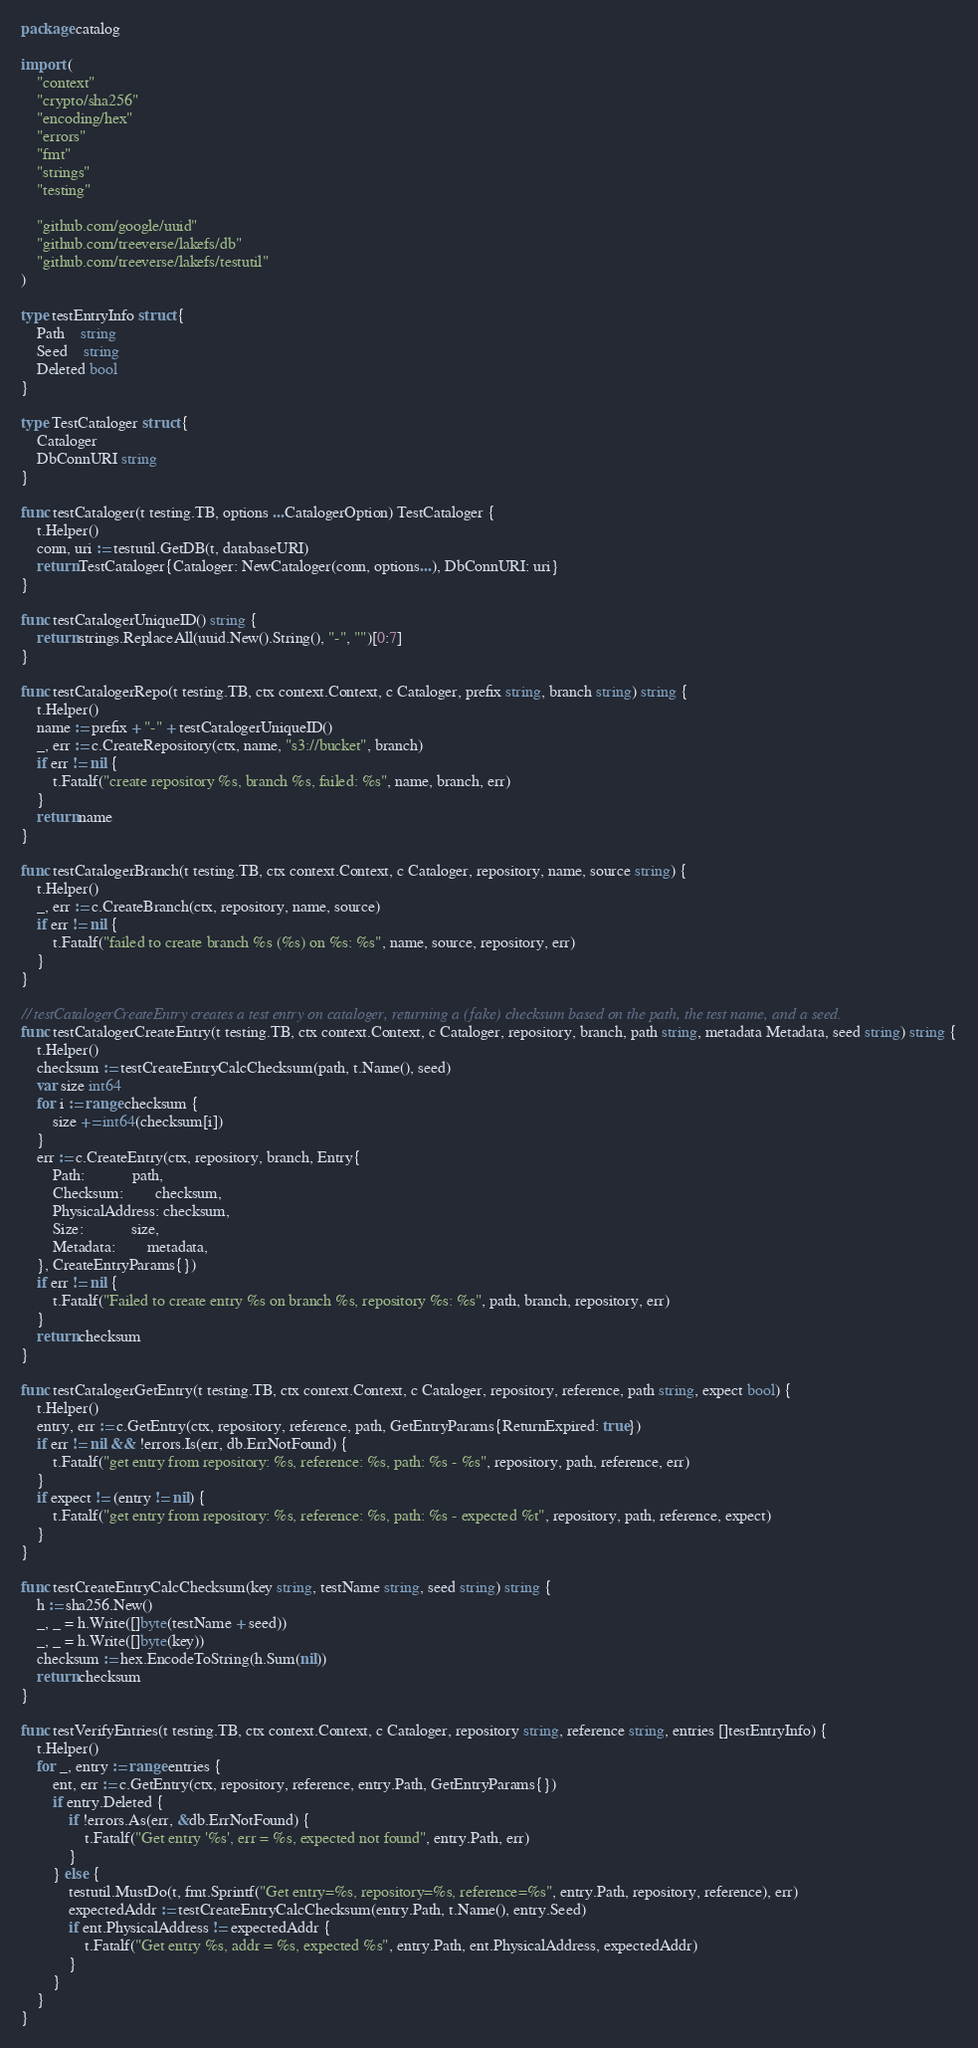<code> <loc_0><loc_0><loc_500><loc_500><_Go_>package catalog

import (
	"context"
	"crypto/sha256"
	"encoding/hex"
	"errors"
	"fmt"
	"strings"
	"testing"

	"github.com/google/uuid"
	"github.com/treeverse/lakefs/db"
	"github.com/treeverse/lakefs/testutil"
)

type testEntryInfo struct {
	Path    string
	Seed    string
	Deleted bool
}

type TestCataloger struct {
	Cataloger
	DbConnURI string
}

func testCataloger(t testing.TB, options ...CatalogerOption) TestCataloger {
	t.Helper()
	conn, uri := testutil.GetDB(t, databaseURI)
	return TestCataloger{Cataloger: NewCataloger(conn, options...), DbConnURI: uri}
}

func testCatalogerUniqueID() string {
	return strings.ReplaceAll(uuid.New().String(), "-", "")[0:7]
}

func testCatalogerRepo(t testing.TB, ctx context.Context, c Cataloger, prefix string, branch string) string {
	t.Helper()
	name := prefix + "-" + testCatalogerUniqueID()
	_, err := c.CreateRepository(ctx, name, "s3://bucket", branch)
	if err != nil {
		t.Fatalf("create repository %s, branch %s, failed: %s", name, branch, err)
	}
	return name
}

func testCatalogerBranch(t testing.TB, ctx context.Context, c Cataloger, repository, name, source string) {
	t.Helper()
	_, err := c.CreateBranch(ctx, repository, name, source)
	if err != nil {
		t.Fatalf("failed to create branch %s (%s) on %s: %s", name, source, repository, err)
	}
}

// testCatalogerCreateEntry creates a test entry on cataloger, returning a (fake) checksum based on the path, the test name, and a seed.
func testCatalogerCreateEntry(t testing.TB, ctx context.Context, c Cataloger, repository, branch, path string, metadata Metadata, seed string) string {
	t.Helper()
	checksum := testCreateEntryCalcChecksum(path, t.Name(), seed)
	var size int64
	for i := range checksum {
		size += int64(checksum[i])
	}
	err := c.CreateEntry(ctx, repository, branch, Entry{
		Path:            path,
		Checksum:        checksum,
		PhysicalAddress: checksum,
		Size:            size,
		Metadata:        metadata,
	}, CreateEntryParams{})
	if err != nil {
		t.Fatalf("Failed to create entry %s on branch %s, repository %s: %s", path, branch, repository, err)
	}
	return checksum
}

func testCatalogerGetEntry(t testing.TB, ctx context.Context, c Cataloger, repository, reference, path string, expect bool) {
	t.Helper()
	entry, err := c.GetEntry(ctx, repository, reference, path, GetEntryParams{ReturnExpired: true})
	if err != nil && !errors.Is(err, db.ErrNotFound) {
		t.Fatalf("get entry from repository: %s, reference: %s, path: %s - %s", repository, path, reference, err)
	}
	if expect != (entry != nil) {
		t.Fatalf("get entry from repository: %s, reference: %s, path: %s - expected %t", repository, path, reference, expect)
	}
}

func testCreateEntryCalcChecksum(key string, testName string, seed string) string {
	h := sha256.New()
	_, _ = h.Write([]byte(testName + seed))
	_, _ = h.Write([]byte(key))
	checksum := hex.EncodeToString(h.Sum(nil))
	return checksum
}

func testVerifyEntries(t testing.TB, ctx context.Context, c Cataloger, repository string, reference string, entries []testEntryInfo) {
	t.Helper()
	for _, entry := range entries {
		ent, err := c.GetEntry(ctx, repository, reference, entry.Path, GetEntryParams{})
		if entry.Deleted {
			if !errors.As(err, &db.ErrNotFound) {
				t.Fatalf("Get entry '%s', err = %s, expected not found", entry.Path, err)
			}
		} else {
			testutil.MustDo(t, fmt.Sprintf("Get entry=%s, repository=%s, reference=%s", entry.Path, repository, reference), err)
			expectedAddr := testCreateEntryCalcChecksum(entry.Path, t.Name(), entry.Seed)
			if ent.PhysicalAddress != expectedAddr {
				t.Fatalf("Get entry %s, addr = %s, expected %s", entry.Path, ent.PhysicalAddress, expectedAddr)
			}
		}
	}
}
</code> 